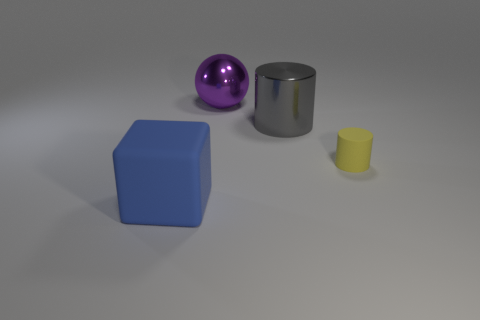Is the number of big gray metal cylinders that are on the left side of the tiny matte thing less than the number of big purple shiny objects in front of the large purple metallic ball?
Offer a terse response. No. What shape is the rubber thing behind the matte thing left of the purple thing?
Offer a terse response. Cylinder. Are there any big blue objects?
Give a very brief answer. Yes. What color is the matte thing that is to the left of the metallic sphere?
Ensure brevity in your answer.  Blue. Are there any big cylinders behind the blue block?
Give a very brief answer. Yes. Is the number of red shiny cylinders greater than the number of purple things?
Provide a succinct answer. No. What is the color of the cylinder behind the rubber object that is behind the thing in front of the small yellow rubber cylinder?
Offer a very short reply. Gray. What color is the large cylinder that is the same material as the purple object?
Provide a succinct answer. Gray. Is there anything else that has the same size as the yellow thing?
Offer a very short reply. No. How many objects are rubber objects that are to the right of the large cylinder or rubber objects to the right of the gray object?
Keep it short and to the point. 1. 